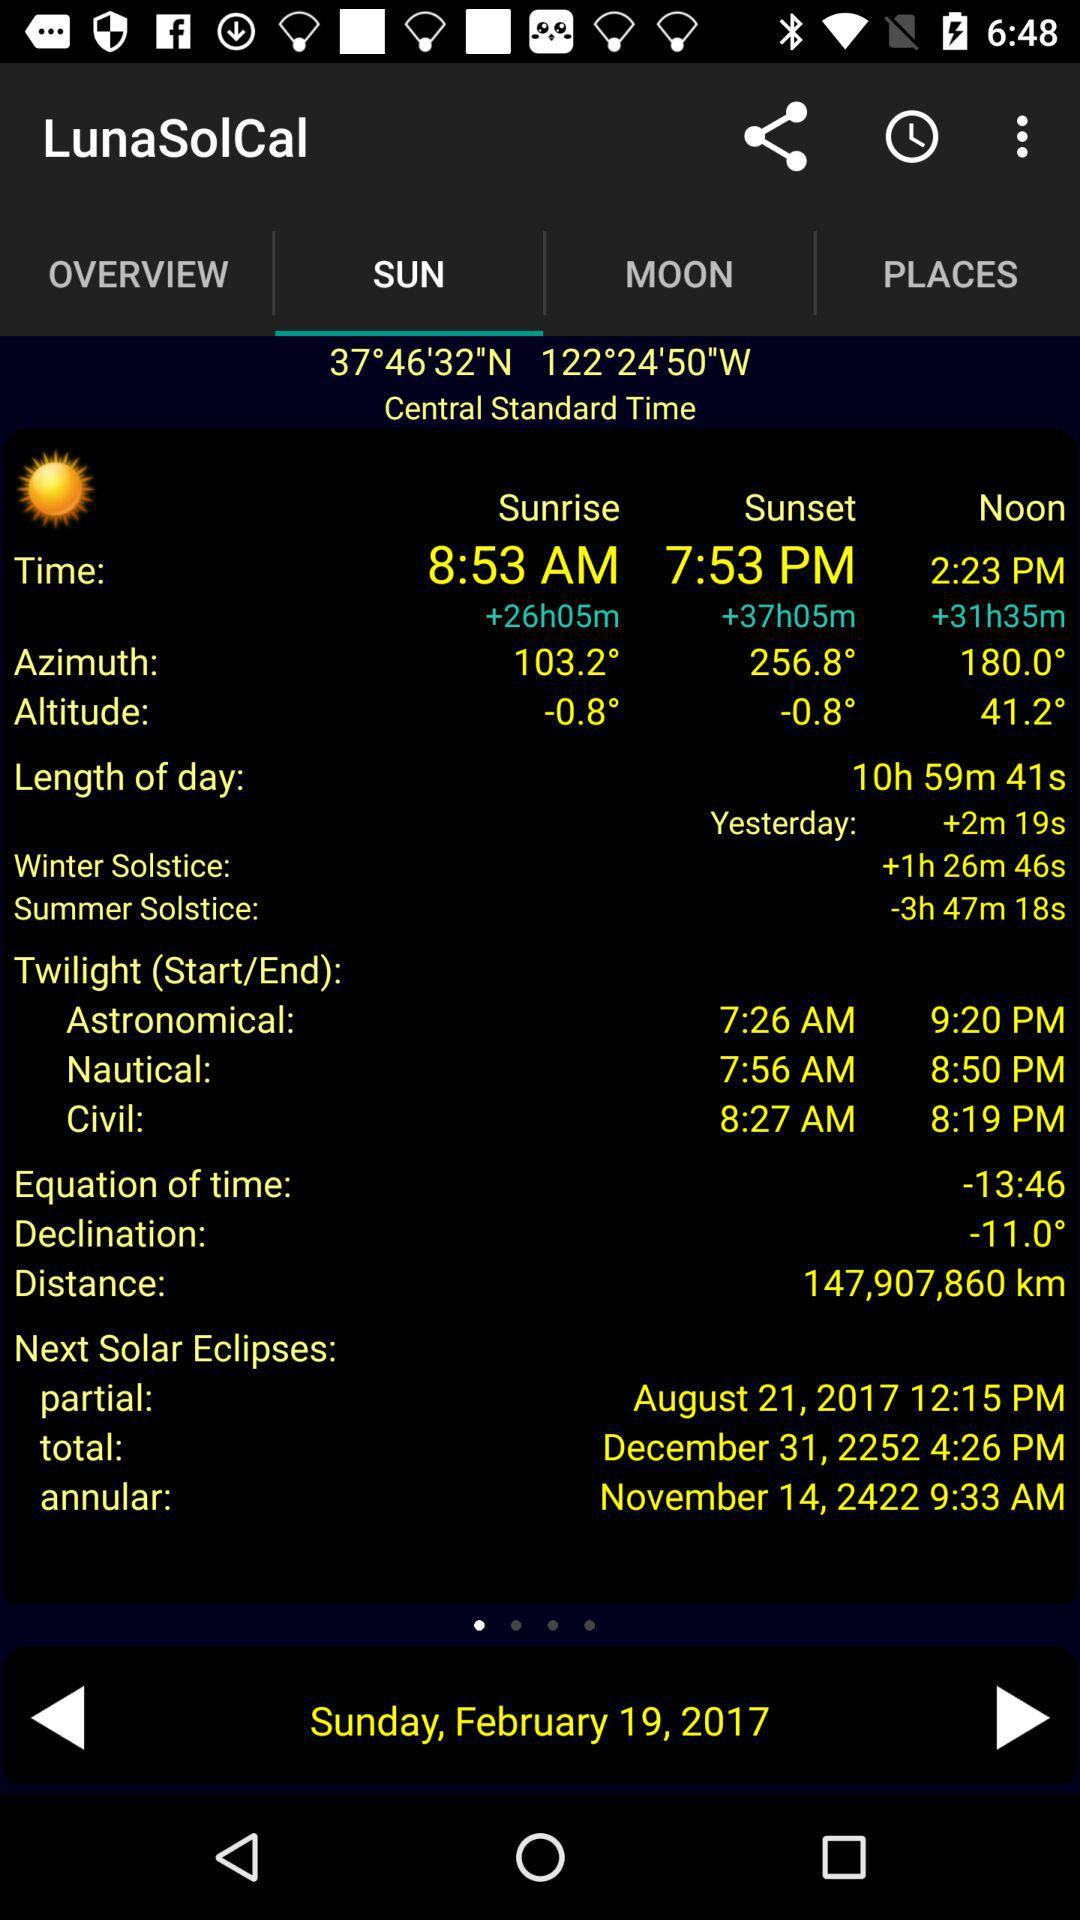What is the sunrise time? The sunrise time is 8:53 AM. 